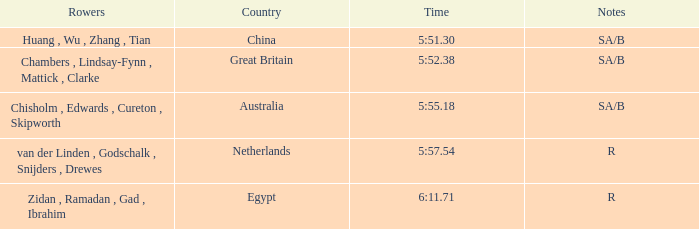Who were the oarsmen when notations were sa/b, with a time of 5:5 Huang , Wu , Zhang , Tian. 